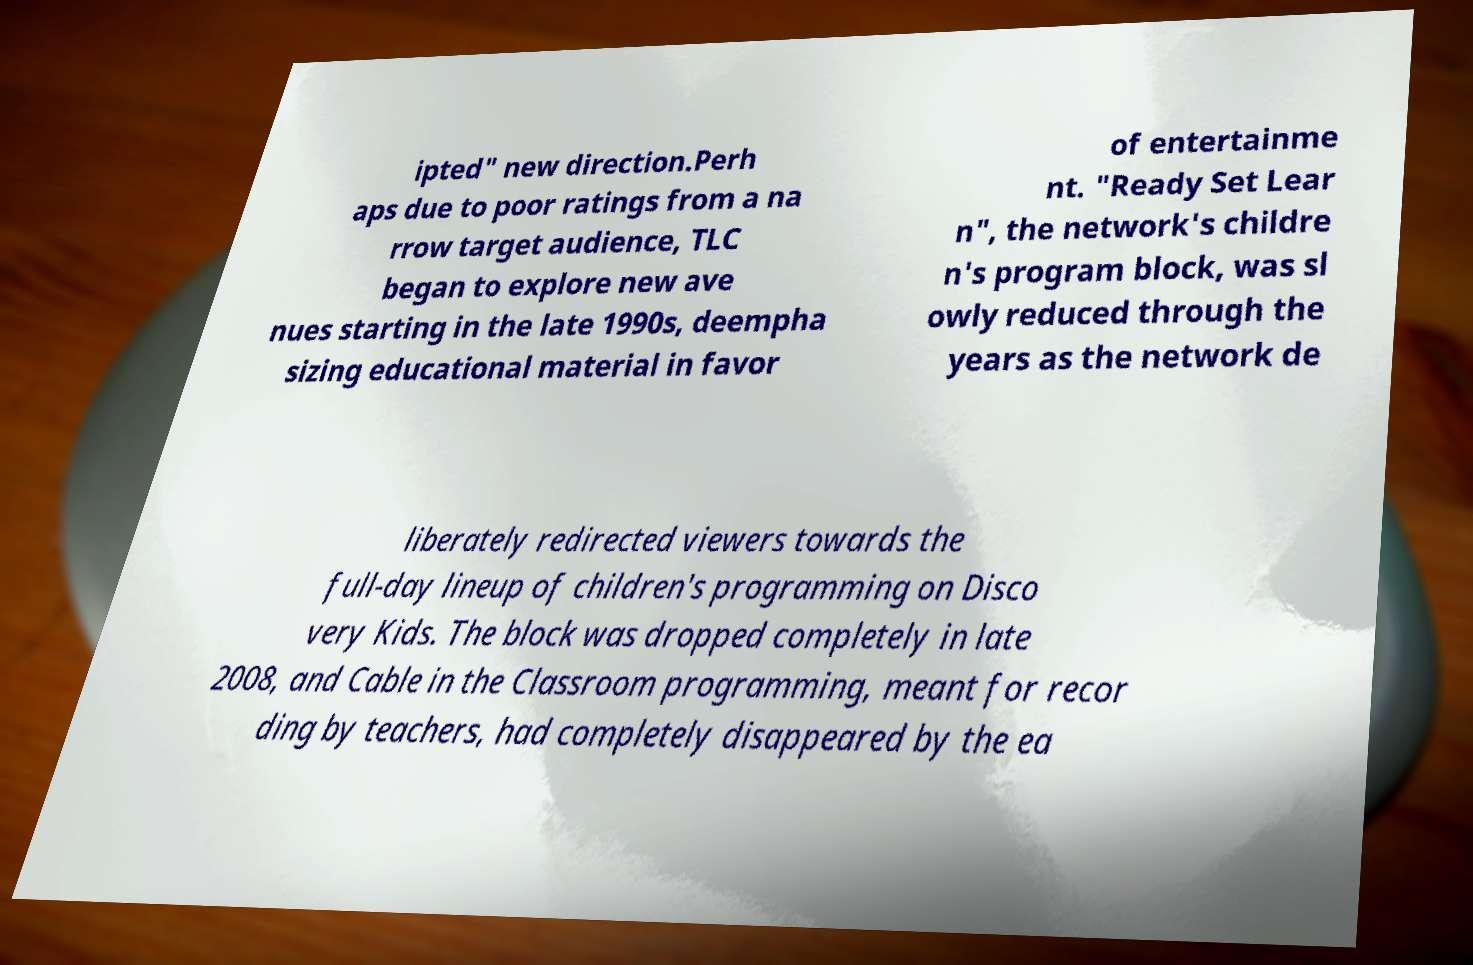Please read and relay the text visible in this image. What does it say? ipted" new direction.Perh aps due to poor ratings from a na rrow target audience, TLC began to explore new ave nues starting in the late 1990s, deempha sizing educational material in favor of entertainme nt. "Ready Set Lear n", the network's childre n's program block, was sl owly reduced through the years as the network de liberately redirected viewers towards the full-day lineup of children's programming on Disco very Kids. The block was dropped completely in late 2008, and Cable in the Classroom programming, meant for recor ding by teachers, had completely disappeared by the ea 